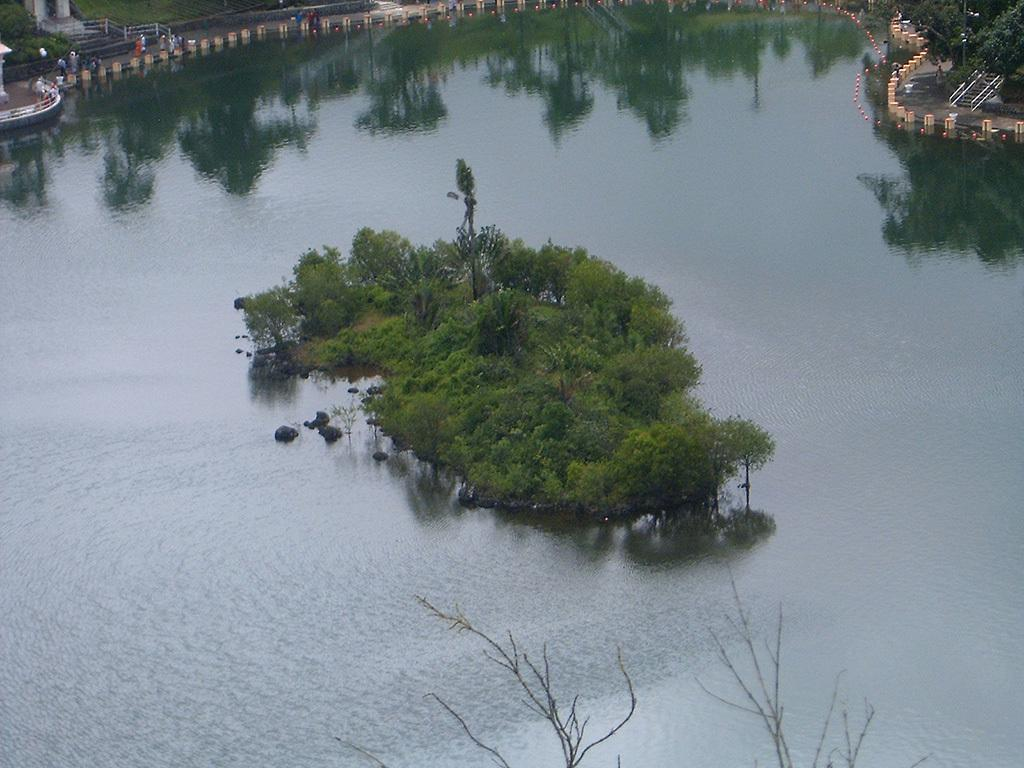What is unusual about the trees in the image? The trees are present on the surface of the water in the image. Can you describe the people visible in the image? The facts provided do not mention any specific details about the people in the image. What other trees can be seen in the image? There are trees present at the top of the image. What does the sister say to the people in the image? There is no mention of a sister or any dialogue in the image, so we cannot answer this question. 